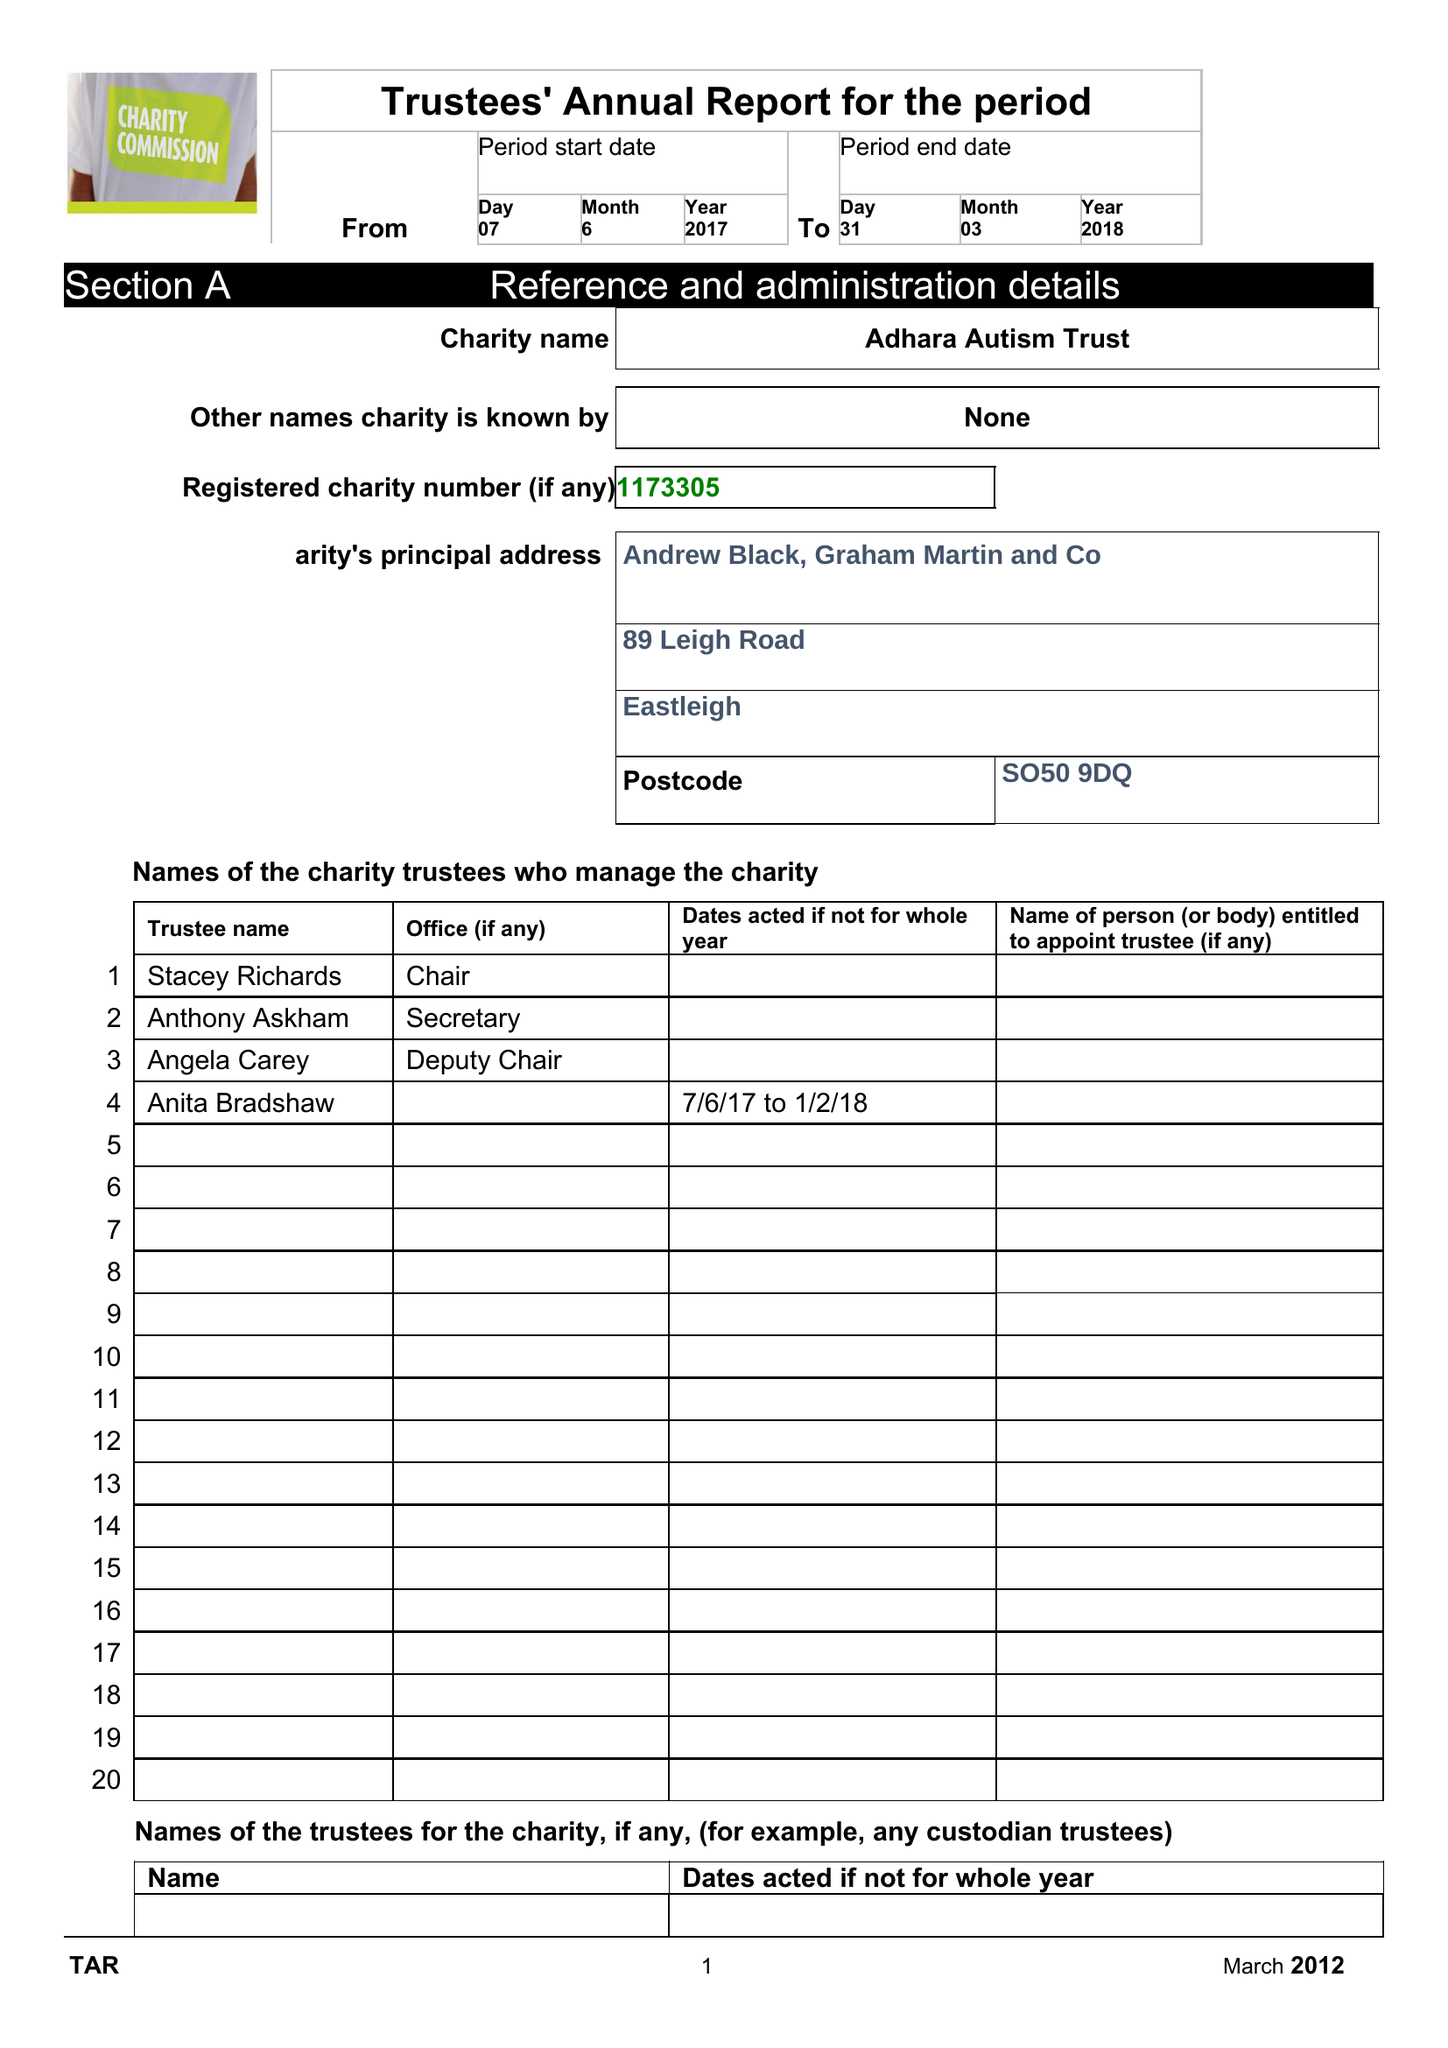What is the value for the address__street_line?
Answer the question using a single word or phrase. 89 LEIGH ROAD 